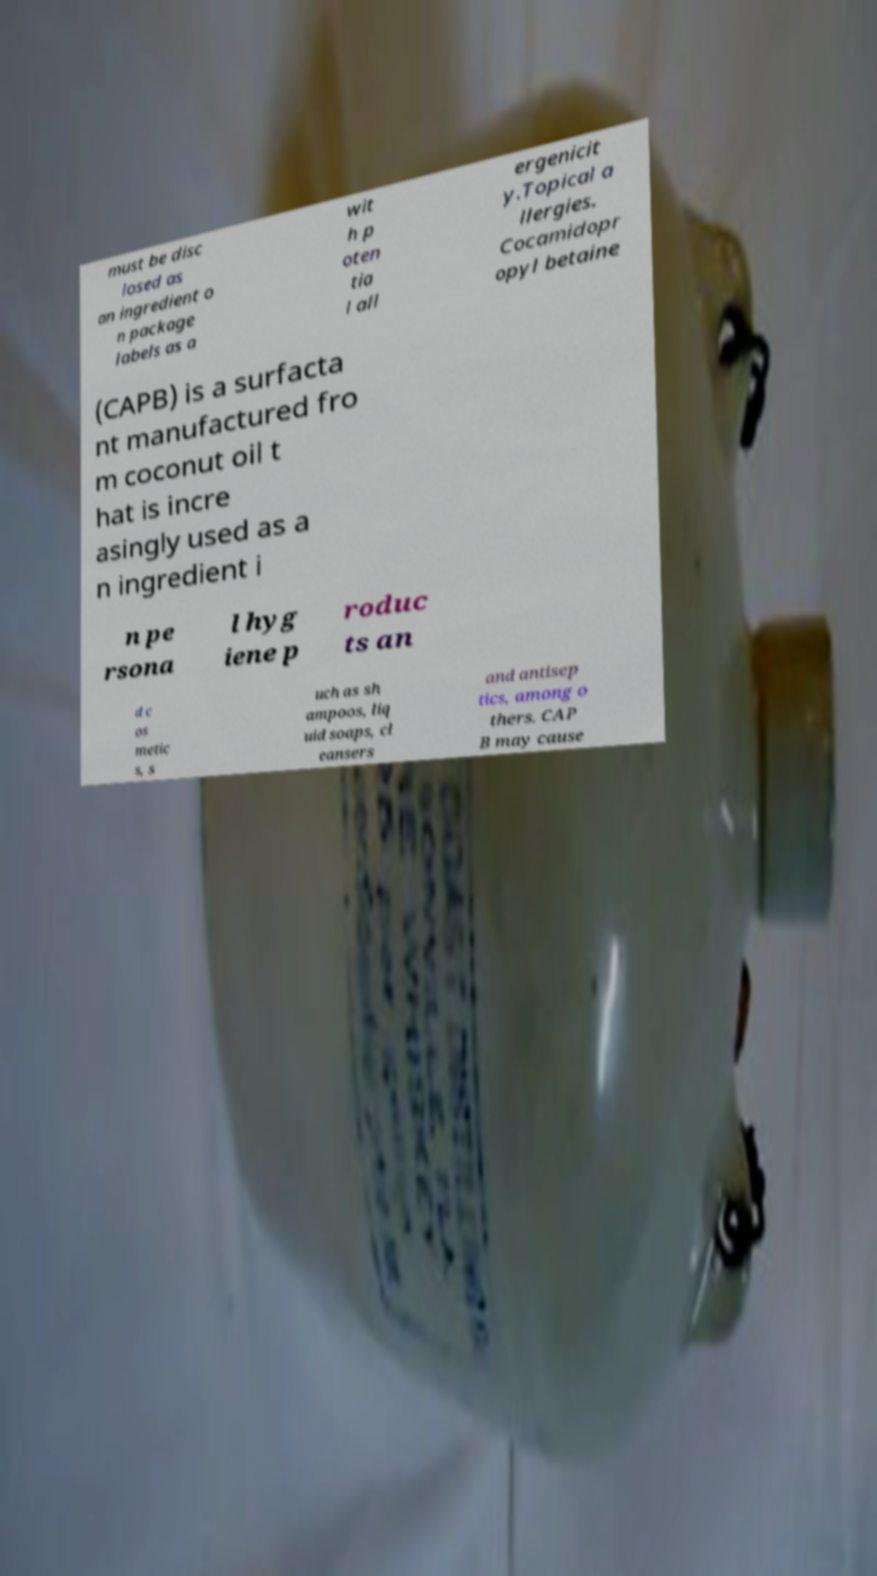Could you assist in decoding the text presented in this image and type it out clearly? must be disc losed as an ingredient o n package labels as a wit h p oten tia l all ergenicit y.Topical a llergies. Cocamidopr opyl betaine (CAPB) is a surfacta nt manufactured fro m coconut oil t hat is incre asingly used as a n ingredient i n pe rsona l hyg iene p roduc ts an d c os metic s, s uch as sh ampoos, liq uid soaps, cl eansers and antisep tics, among o thers. CAP B may cause 